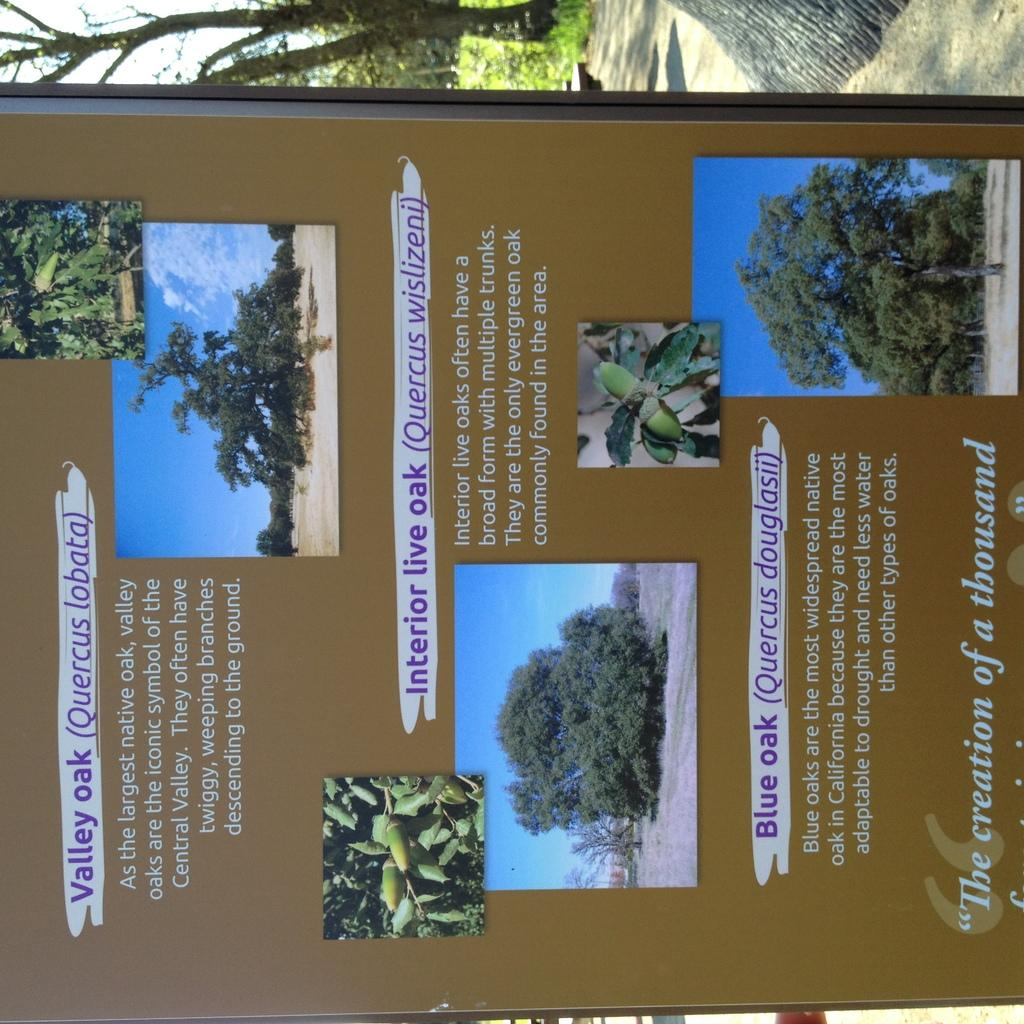What is featured in the image? There is a poster in the image. What is depicted on the poster? The poster contains pictures of trees. Can you describe the background of the image? There are trees visible in the background of the image. Is there a band playing in the background of the image? No, there is no band present in the image. 